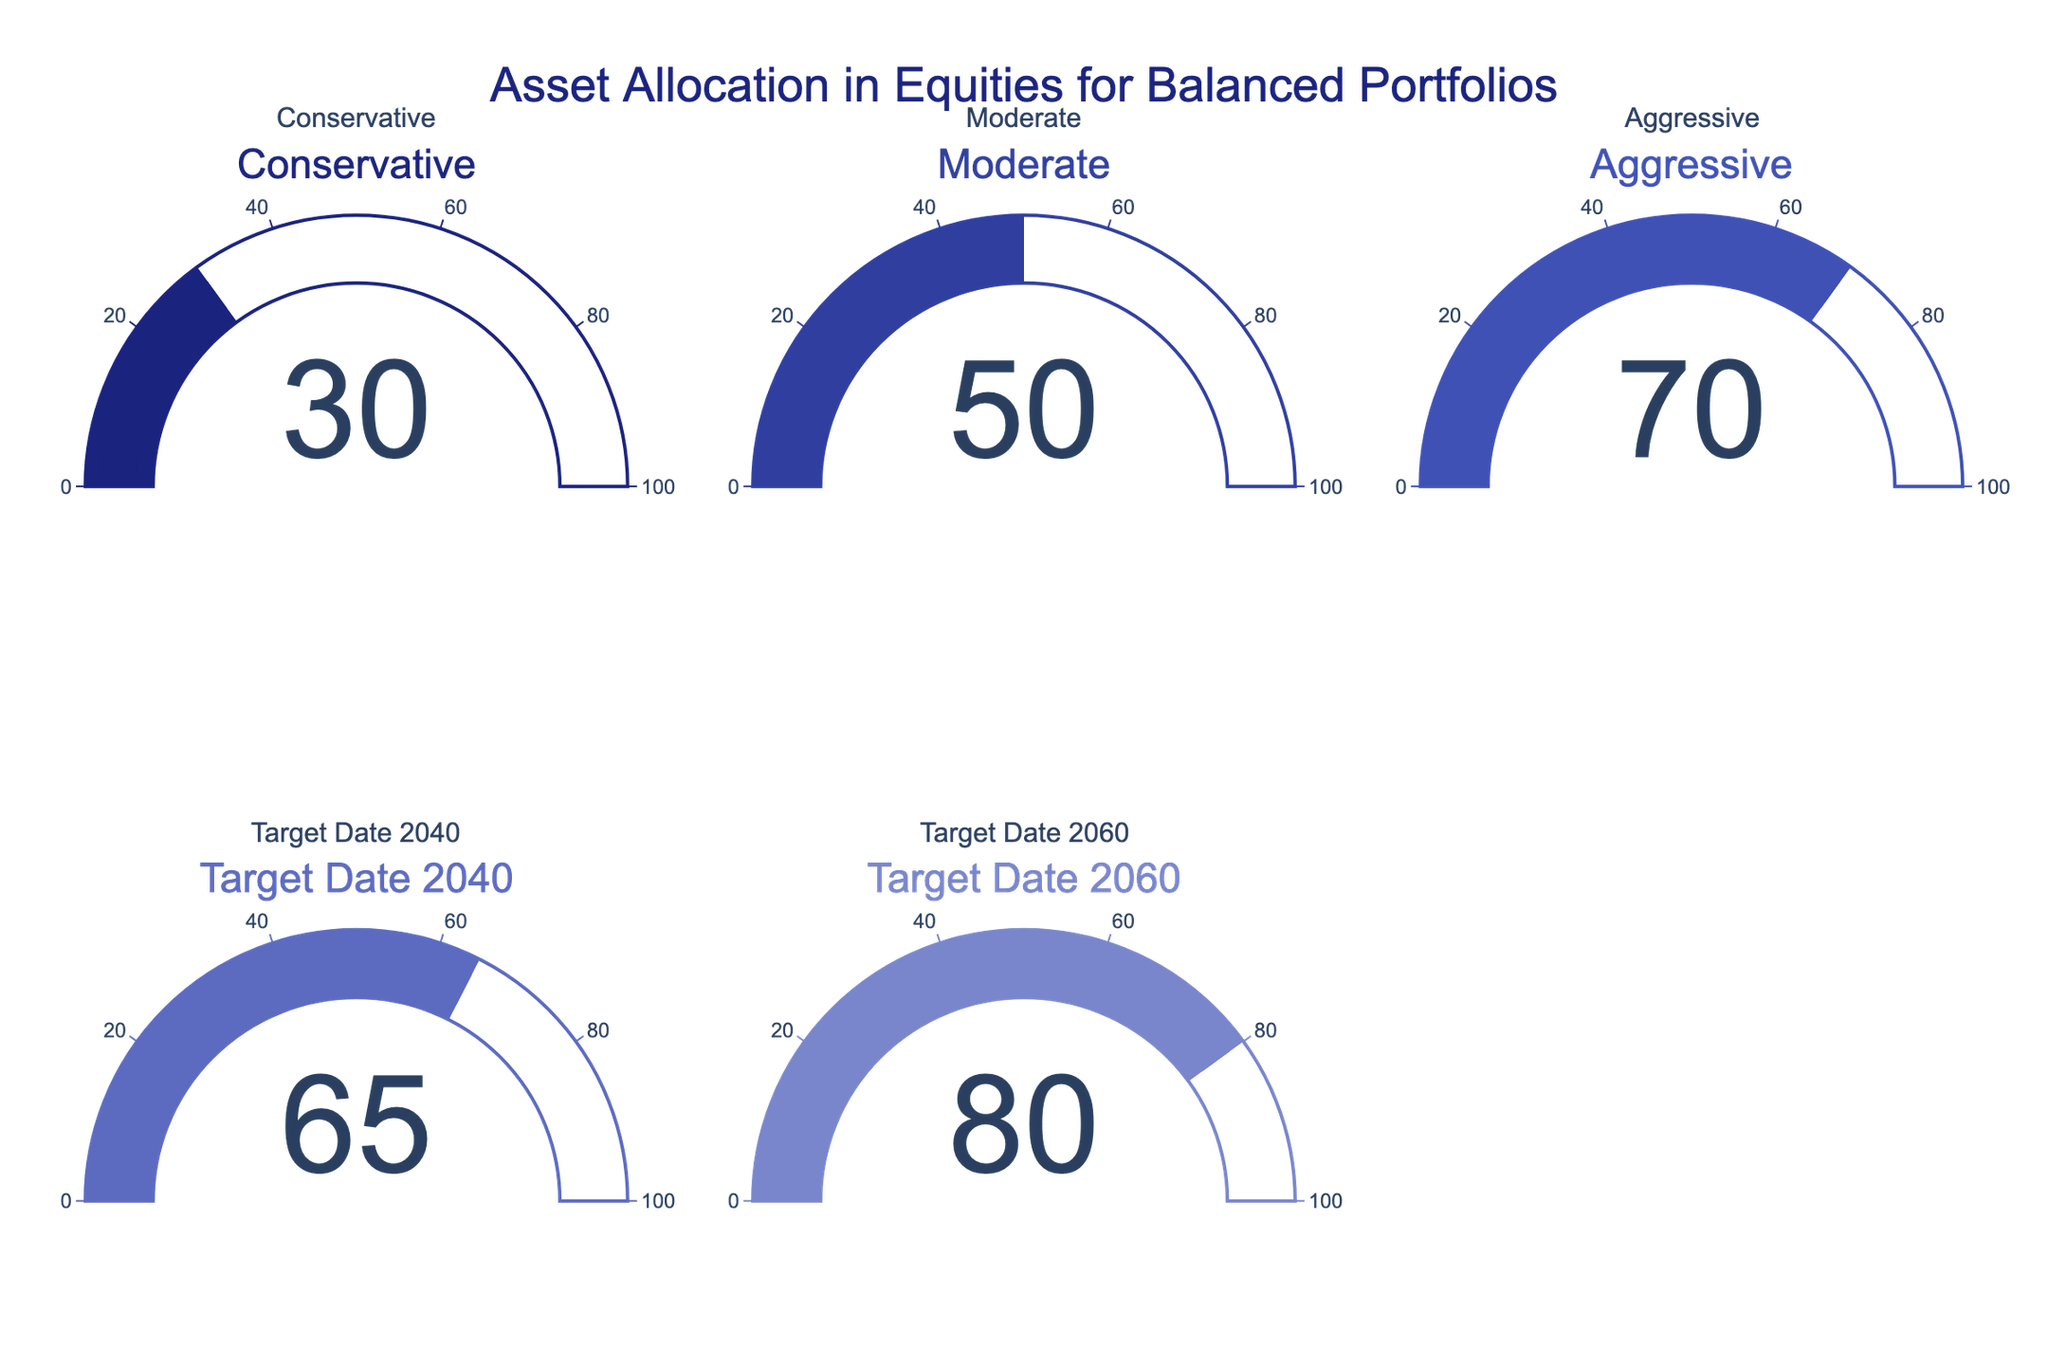What is the title of the figure? The title is located at the top of the figure and is displayed prominently. It reads: "Asset Allocation in Equities for Balanced Portfolios".
Answer: Asset Allocation in Equities for Balanced Portfolios How many categories of asset allocation in equities are present in the figure? The figure consists of five gauges, each representing a different category. They are Conservative, Moderate, Aggressive, Target Date 2040, and Target Date 2060.
Answer: 5 What is the percentage allocation in equities for the Moderate category? The gauge for the Moderate category indicates a value. By referring to the figure, we see that the value is 50.
Answer: 50 Which category has the highest percentage of asset allocation in equities? By comparing the values displayed on each of the gauge charts, Target Date 2060 has the highest percentage with a value of 80.
Answer: Target Date 2060 What is the difference in percentage allocation between the Conservative and Aggressive categories? The gauge for Conservative shows 30, and for Aggressive, it shows 70. The difference is calculated as 70 - 30.
Answer: 40 Which category has an asset allocation percentage closest to the Aggressive category? The values to compare are Conservative (30), Moderate (50), Aggressive (70), Target Date 2040 (65), and Target Date 2060 (80). The closest value to Aggressive (70) is Target Date 2040 with 65.
Answer: Target Date 2040 What is the average percentage allocation in equities for all categories combined? Add the percentages of all the categories (30 + 50 + 70 + 65 + 80) and then divide by the number of categories (5). The sum is 295, and the average is calculated as 295 / 5.
Answer: 59 How does the percentage allocation in equities for Target Date 2060 compare to Conservative? The gauge for Target Date 2060 shows 80, and for Conservative, it shows 30. Since 80 is greater than 30, Target Date 2060 has a higher allocation.
Answer: Target Date 2060 is higher Which categories have a percentage allocation in equities greater than 60%? From the values displayed: Aggressive (70), Target Date 2040 (65), and Target Date 2060 (80) are all greater than 60%.
Answer: Aggressive, Target Date 2040, Target Date 2060 What is the total percentage allocation in equities for all Target Date strategies? The Target Date strategies are 2040 and 2060 with values of 65 and 80 respectively. Summing these values gives 65 + 80.
Answer: 145 